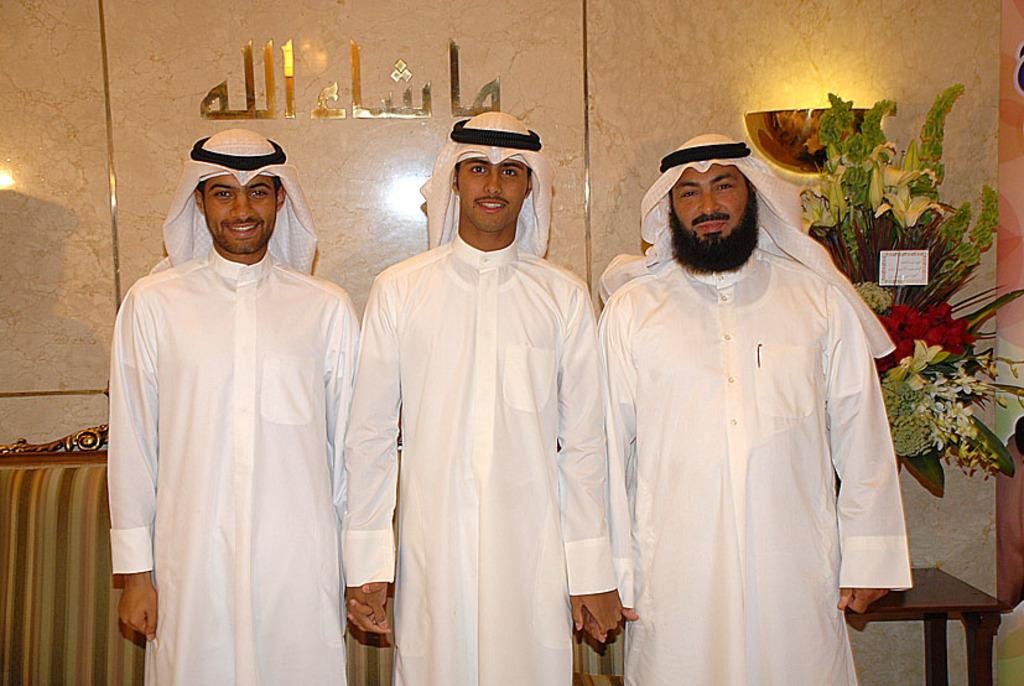How many men are in the image? There are three men in the image. What are the men wearing? The men are wearing the same dress. What expression do the men have? The men are smiling. What furniture can be seen in the background of the image? There is a sofa and a table in the background of the image. What decorative items are on the table? There are flowers on the table. What is visible on the wall in the background of the image? There is a wall visible in the background of the image. What type of marble is visible on the floor in the image? There is no marble visible on the floor in the image. What kind of plants are growing on the men's heads in the image? There are no plants growing on the men's heads in the image. 